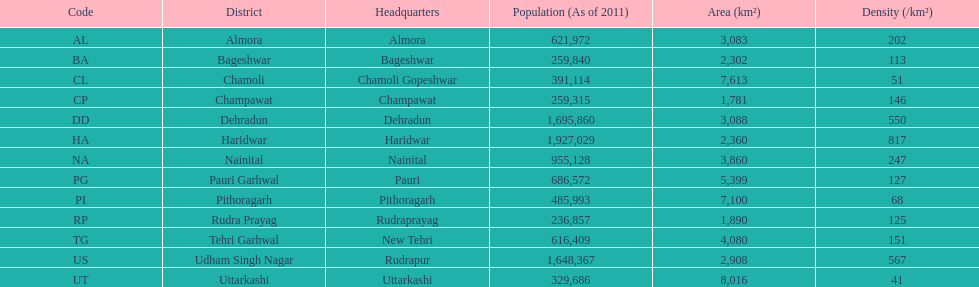Can you provide a district with a population density of only 51? Chamoli. 